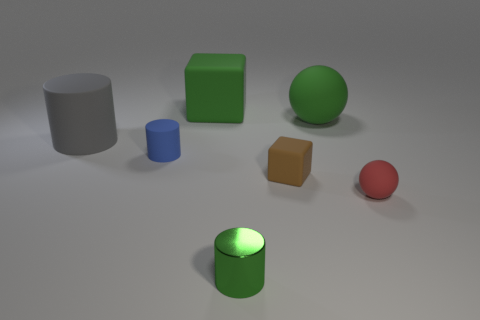Is there anything else that is made of the same material as the green cylinder?
Make the answer very short. No. Does the blue matte object have the same shape as the green object that is in front of the small brown block?
Ensure brevity in your answer.  Yes. How many other things are there of the same shape as the brown matte thing?
Your answer should be very brief. 1. There is a object that is on the right side of the tiny brown block and behind the brown cube; what color is it?
Provide a succinct answer. Green. The metallic object is what color?
Make the answer very short. Green. Are the brown cube and the green cube that is right of the large gray matte object made of the same material?
Keep it short and to the point. Yes. The green object that is made of the same material as the large cube is what shape?
Your answer should be compact. Sphere. There is a block that is the same size as the red rubber sphere; what color is it?
Make the answer very short. Brown. Do the cylinder that is in front of the blue matte object and the gray rubber object have the same size?
Your answer should be very brief. No. Is the color of the shiny cylinder the same as the large sphere?
Ensure brevity in your answer.  Yes. 